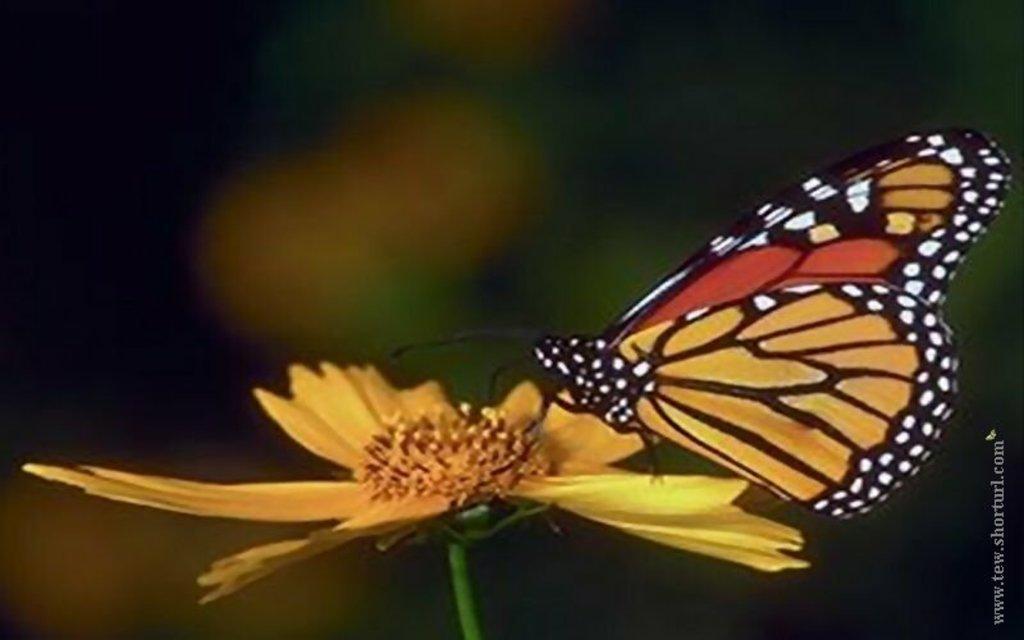In one or two sentences, can you explain what this image depicts? In this image we can see a butterfly on a flower and also some text on the image. 